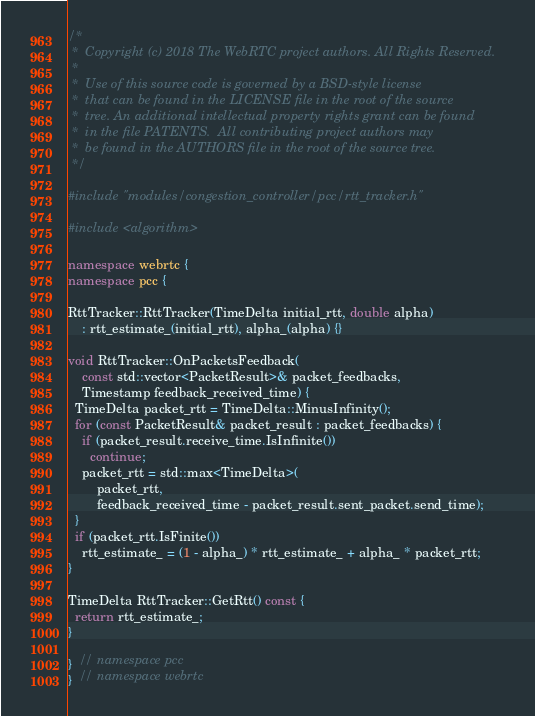Convert code to text. <code><loc_0><loc_0><loc_500><loc_500><_C++_>/*
 *  Copyright (c) 2018 The WebRTC project authors. All Rights Reserved.
 *
 *  Use of this source code is governed by a BSD-style license
 *  that can be found in the LICENSE file in the root of the source
 *  tree. An additional intellectual property rights grant can be found
 *  in the file PATENTS.  All contributing project authors may
 *  be found in the AUTHORS file in the root of the source tree.
 */

#include "modules/congestion_controller/pcc/rtt_tracker.h"

#include <algorithm>

namespace webrtc {
namespace pcc {

RttTracker::RttTracker(TimeDelta initial_rtt, double alpha)
    : rtt_estimate_(initial_rtt), alpha_(alpha) {}

void RttTracker::OnPacketsFeedback(
    const std::vector<PacketResult>& packet_feedbacks,
    Timestamp feedback_received_time) {
  TimeDelta packet_rtt = TimeDelta::MinusInfinity();
  for (const PacketResult& packet_result : packet_feedbacks) {
    if (packet_result.receive_time.IsInfinite())
      continue;
    packet_rtt = std::max<TimeDelta>(
        packet_rtt,
        feedback_received_time - packet_result.sent_packet.send_time);
  }
  if (packet_rtt.IsFinite())
    rtt_estimate_ = (1 - alpha_) * rtt_estimate_ + alpha_ * packet_rtt;
}

TimeDelta RttTracker::GetRtt() const {
  return rtt_estimate_;
}

}  // namespace pcc
}  // namespace webrtc
</code> 